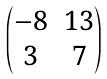Convert formula to latex. <formula><loc_0><loc_0><loc_500><loc_500>\begin{pmatrix} - 8 & 1 3 \\ 3 & 7 \end{pmatrix}</formula> 